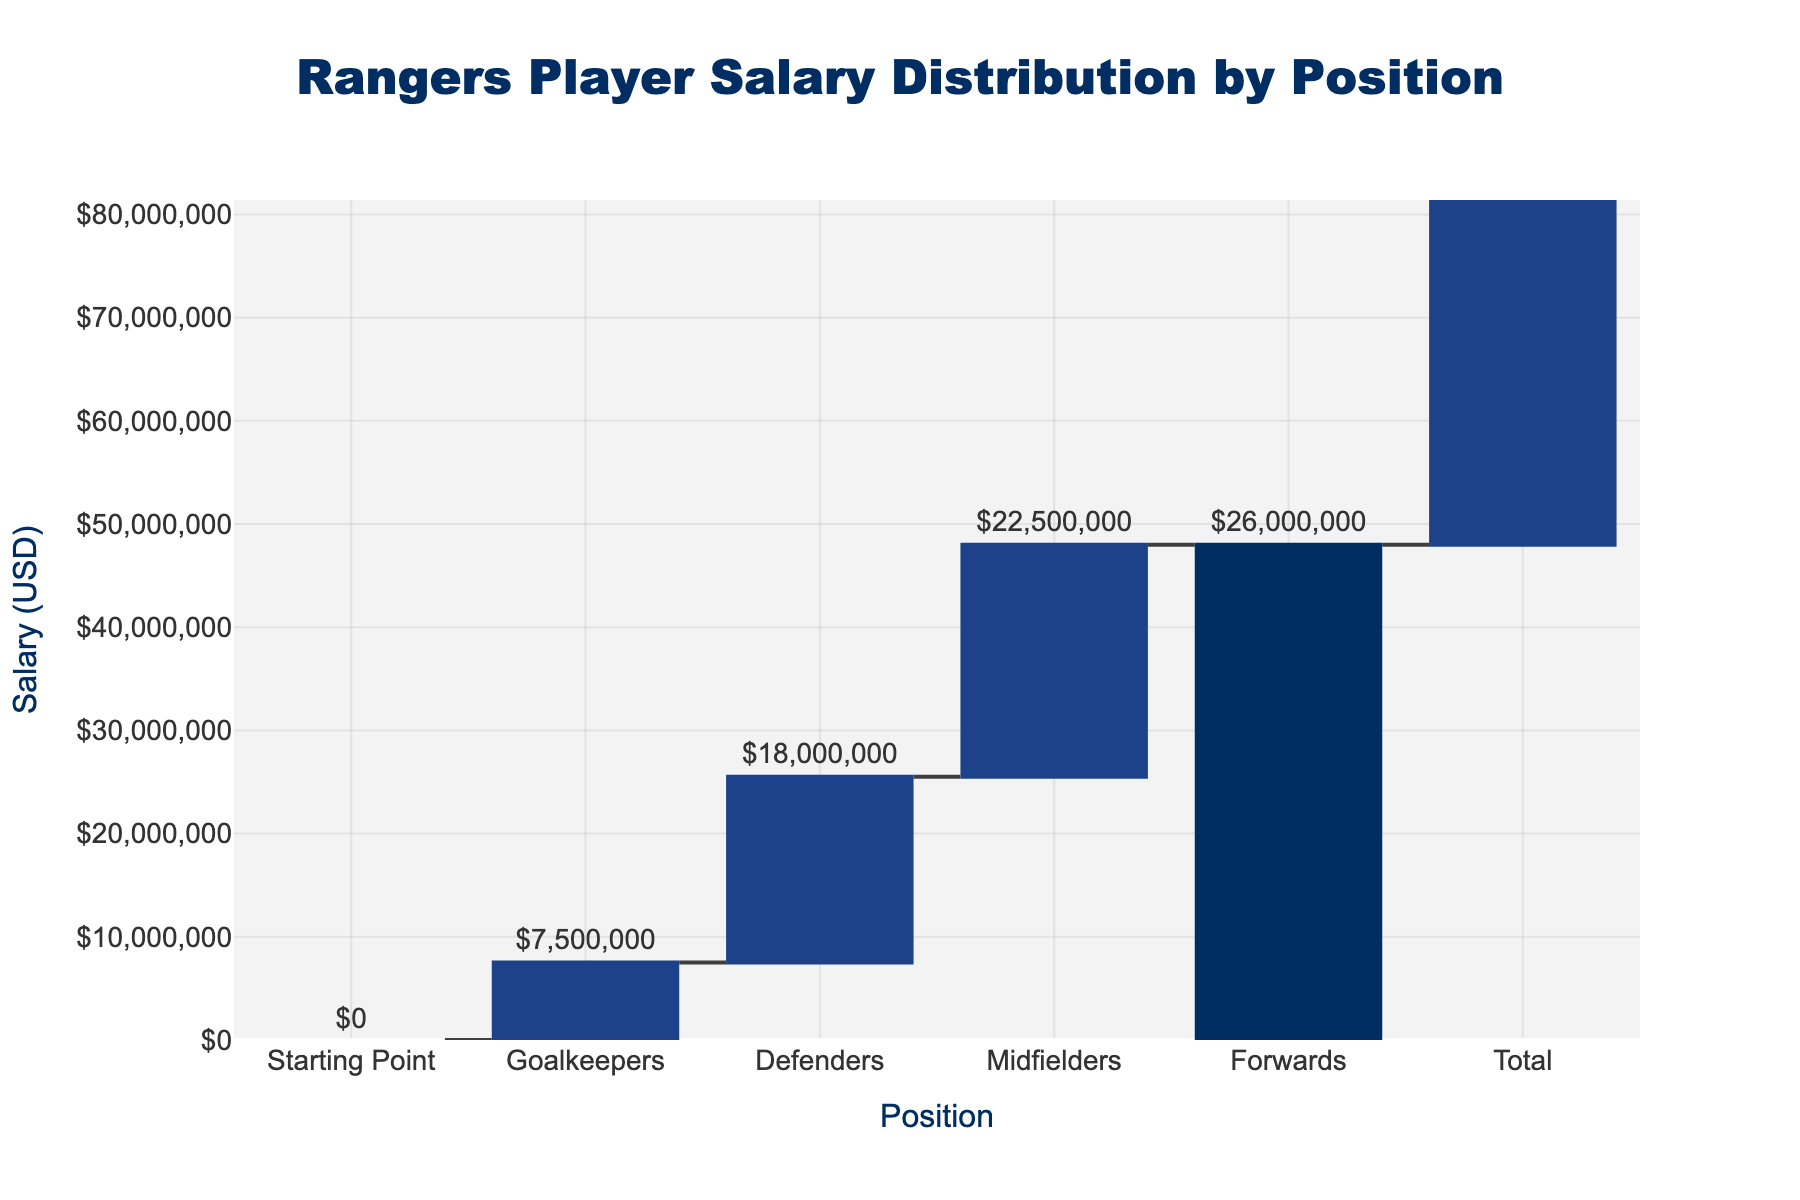What is the title of the chart? The title is displayed at the top of the chart, often using a larger and bolder font. In this case, it reads "Rangers Player Salary Distribution by Position".
Answer: Rangers Player Salary Distribution by Position Which position has the highest salary? From the chart, we observe that the "Forwards" bar has the highest value among all listed positions.
Answer: Forwards What is the salary for Midfielders? Identify the bar labeled "Midfielders" and read the value associated with it. The text outside the bar indicates the salary amount.
Answer: $22,500,000 How much more is the total salary compared to the starting point? The starting point is $0, and the total salary is $74,000,000. Subtracting the starting point value from the total salary gives us the difference. 74,000,000 - 0 = 74,000,000
Answer: $74,000,000 By how much do the Defenders' salaries exceed the Goalkeepers'? Find the salary values for both Defenders ($18,000,000) and Goalkeepers ($7,500,000). Compute the difference: $18,000,000 - $7,500,000 = $10,500,000.
Answer: $10,500,000 What is the average salary across all positions? Sum salary values of all positions (7,500,000 + 18,000,000 + 22,500,000 + 26,000,000 = 74,000,000) and divide by the number of positions (4). (74,000,000 / 4) gives $18,500,000.
Answer: $18,500,000 What is the salary increase from Midfielders to Forwards? Extract the salary values for both Midfielders ($22,500,000) and Forwards ($26,000,000), then calculate the difference: $26,000,000 - $22,500,000 = $3,500,000.
Answer: $3,500,000 Which position's salary is closest to the average salary across all positions? First calculate the average salary: 74,000,000 / 4 = $18,500,000. Compare this value to each position's salary: Goalkeepers ($7,500,000), Defenders ($18,000,000), Midfielders ($22,500,000), Forwards ($26,000,000). The salary closest to $18,500,000 is Defenders’ $18,000,000 which is just $500,000 less.
Answer: Defenders What proportion of the total salary is allocated to the Forwards? Find the total salary is $74,000,000 and the Forwards’ salary is $26,000,000. The proportion is calculated as (26,000,000 / 74,000,000) = approximately 0.351, or 35.1%.
Answer: 35.1% In terms of salary, which positions have shown an increase and which have a decrease based on the colors used? In waterfall charts, increasing values are usually shown in one color, and decreasing in another. For this chart, Goalkeepers, Defenders, Midfielders, and Forwards are in increasing colors, implying all have increased. Total is in a different color to indicate the final sum.
Answer: All positions have increased 